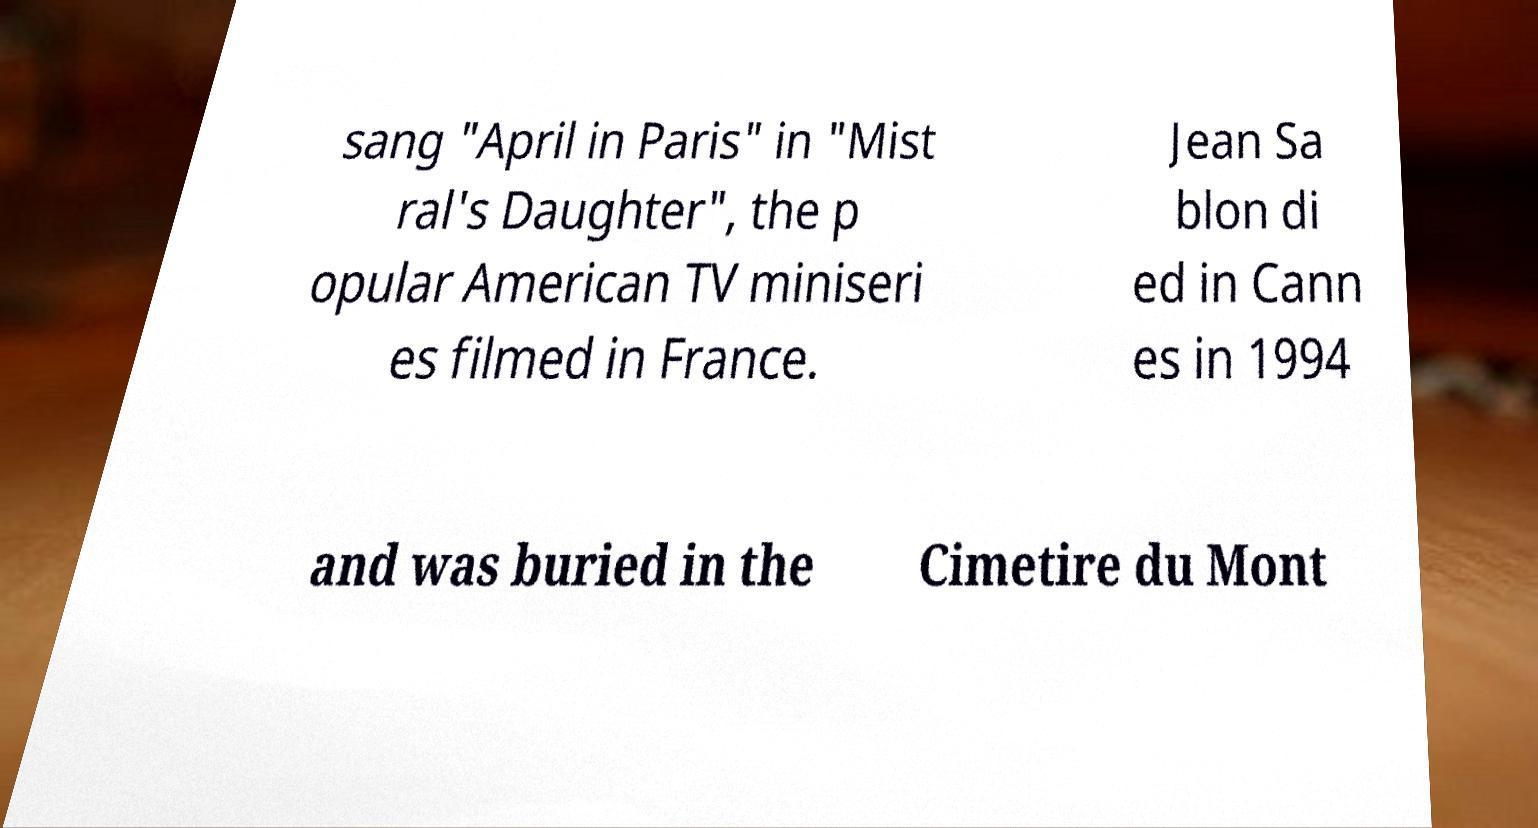Please identify and transcribe the text found in this image. sang "April in Paris" in "Mist ral's Daughter", the p opular American TV miniseri es filmed in France. Jean Sa blon di ed in Cann es in 1994 and was buried in the Cimetire du Mont 